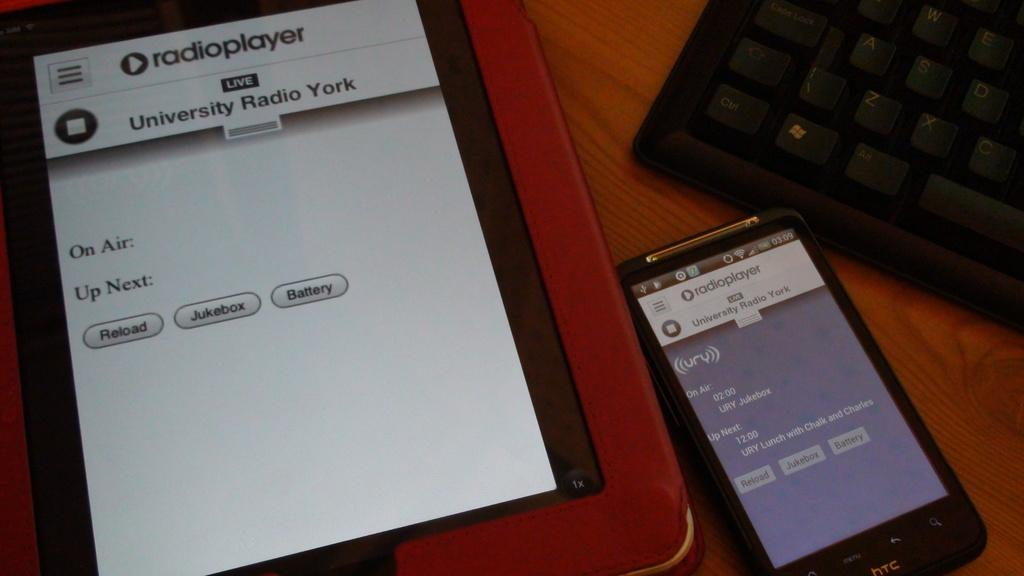Provide a one-sentence caption for the provided image. A tablet and a smartphone are shown with an app called radioplayer open. 